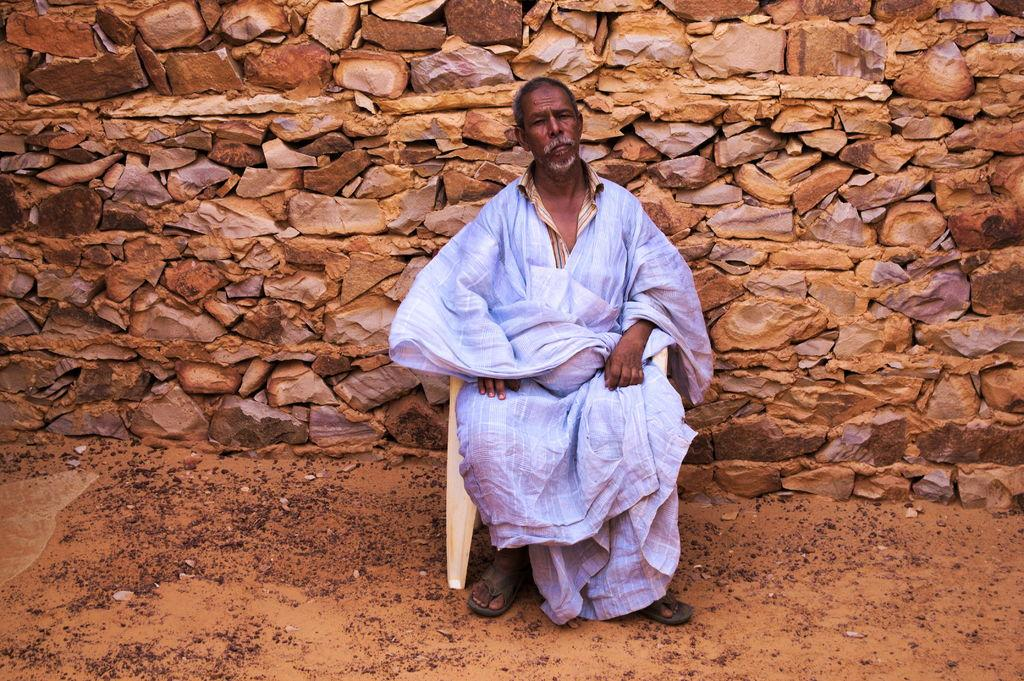What is the main subject of the image? There is a person in the image. What is the person doing in the image? The person is sitting on a chair. What can be seen in the background of the image? There is a wall in the background of the image. What type of wool is the person wearing in the image? There is no mention of wool or any clothing in the image, so it cannot be determined what type of wool the person might be wearing. 